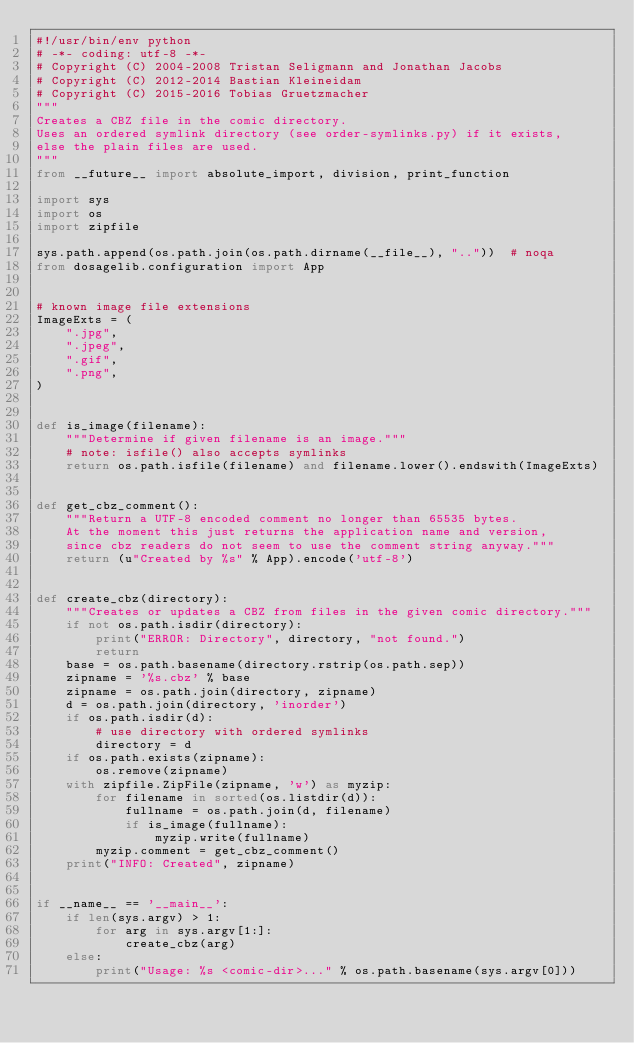<code> <loc_0><loc_0><loc_500><loc_500><_Python_>#!/usr/bin/env python
# -*- coding: utf-8 -*-
# Copyright (C) 2004-2008 Tristan Seligmann and Jonathan Jacobs
# Copyright (C) 2012-2014 Bastian Kleineidam
# Copyright (C) 2015-2016 Tobias Gruetzmacher
"""
Creates a CBZ file in the comic directory.
Uses an ordered symlink directory (see order-symlinks.py) if it exists,
else the plain files are used.
"""
from __future__ import absolute_import, division, print_function

import sys
import os
import zipfile

sys.path.append(os.path.join(os.path.dirname(__file__), ".."))  # noqa
from dosagelib.configuration import App


# known image file extensions
ImageExts = (
    ".jpg",
    ".jpeg",
    ".gif",
    ".png",
)


def is_image(filename):
    """Determine if given filename is an image."""
    # note: isfile() also accepts symlinks
    return os.path.isfile(filename) and filename.lower().endswith(ImageExts)


def get_cbz_comment():
    """Return a UTF-8 encoded comment no longer than 65535 bytes.
    At the moment this just returns the application name and version,
    since cbz readers do not seem to use the comment string anyway."""
    return (u"Created by %s" % App).encode('utf-8')


def create_cbz(directory):
    """Creates or updates a CBZ from files in the given comic directory."""
    if not os.path.isdir(directory):
        print("ERROR: Directory", directory, "not found.")
        return
    base = os.path.basename(directory.rstrip(os.path.sep))
    zipname = '%s.cbz' % base
    zipname = os.path.join(directory, zipname)
    d = os.path.join(directory, 'inorder')
    if os.path.isdir(d):
        # use directory with ordered symlinks
        directory = d
    if os.path.exists(zipname):
        os.remove(zipname)
    with zipfile.ZipFile(zipname, 'w') as myzip:
        for filename in sorted(os.listdir(d)):
            fullname = os.path.join(d, filename)
            if is_image(fullname):
                myzip.write(fullname)
        myzip.comment = get_cbz_comment()
    print("INFO: Created", zipname)


if __name__ == '__main__':
    if len(sys.argv) > 1:
        for arg in sys.argv[1:]:
            create_cbz(arg)
    else:
        print("Usage: %s <comic-dir>..." % os.path.basename(sys.argv[0]))
</code> 